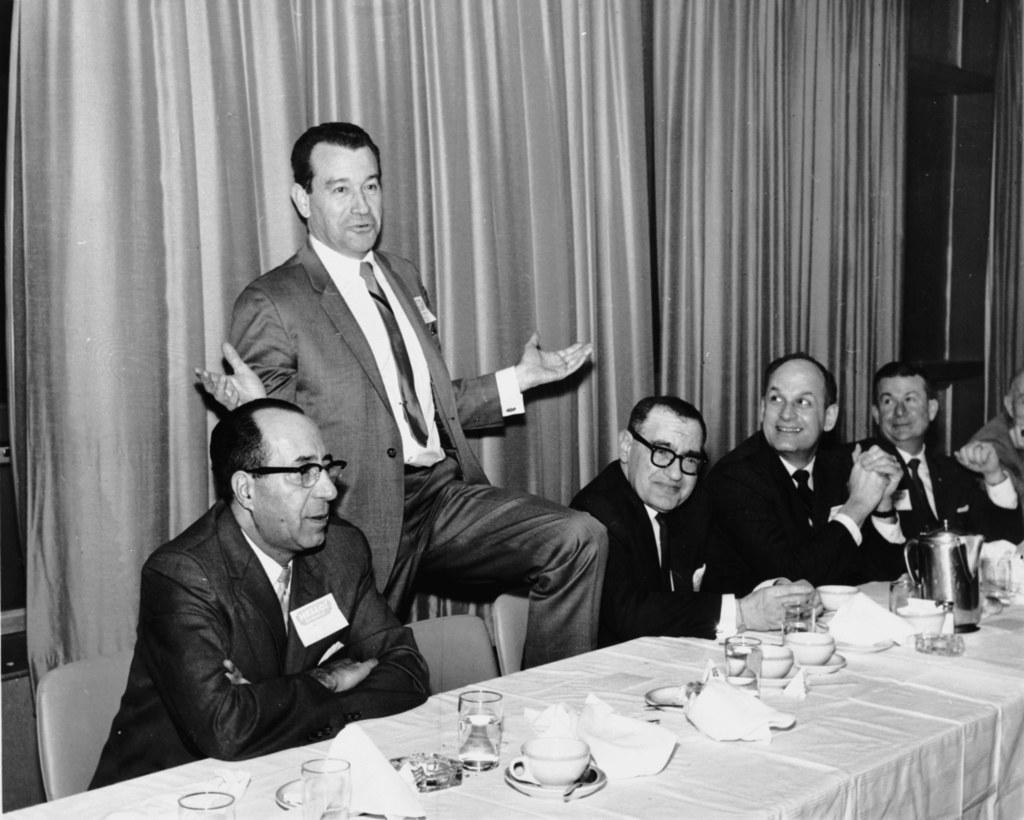How would you summarize this image in a sentence or two? The person who is standing has placed one of his leg on a chair and there are group of persons sitting beside him and there is a table in front of them. 